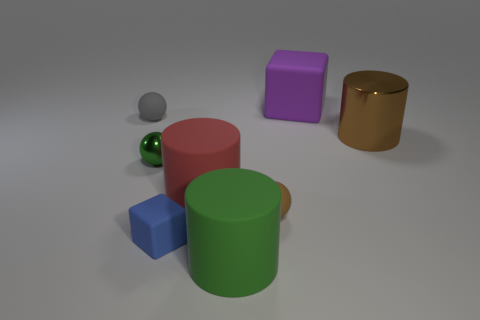What number of other large rubber cubes have the same color as the large rubber cube?
Offer a terse response. 0. Is the color of the big metallic object the same as the shiny sphere?
Provide a short and direct response. No. What is the cylinder to the right of the large purple block made of?
Make the answer very short. Metal. What number of small objects are either red spheres or brown things?
Your answer should be very brief. 1. What is the material of the sphere that is the same color as the large metallic cylinder?
Offer a very short reply. Rubber. Are there any gray blocks made of the same material as the big brown object?
Your answer should be compact. No. There is a metal object right of the purple block; does it have the same size as the tiny blue object?
Give a very brief answer. No. There is a big thing behind the large object right of the large cube; are there any small green metallic spheres behind it?
Offer a terse response. No. What number of metal things are large brown cylinders or tiny gray blocks?
Your response must be concise. 1. What number of other objects are there of the same shape as the blue object?
Give a very brief answer. 1. 